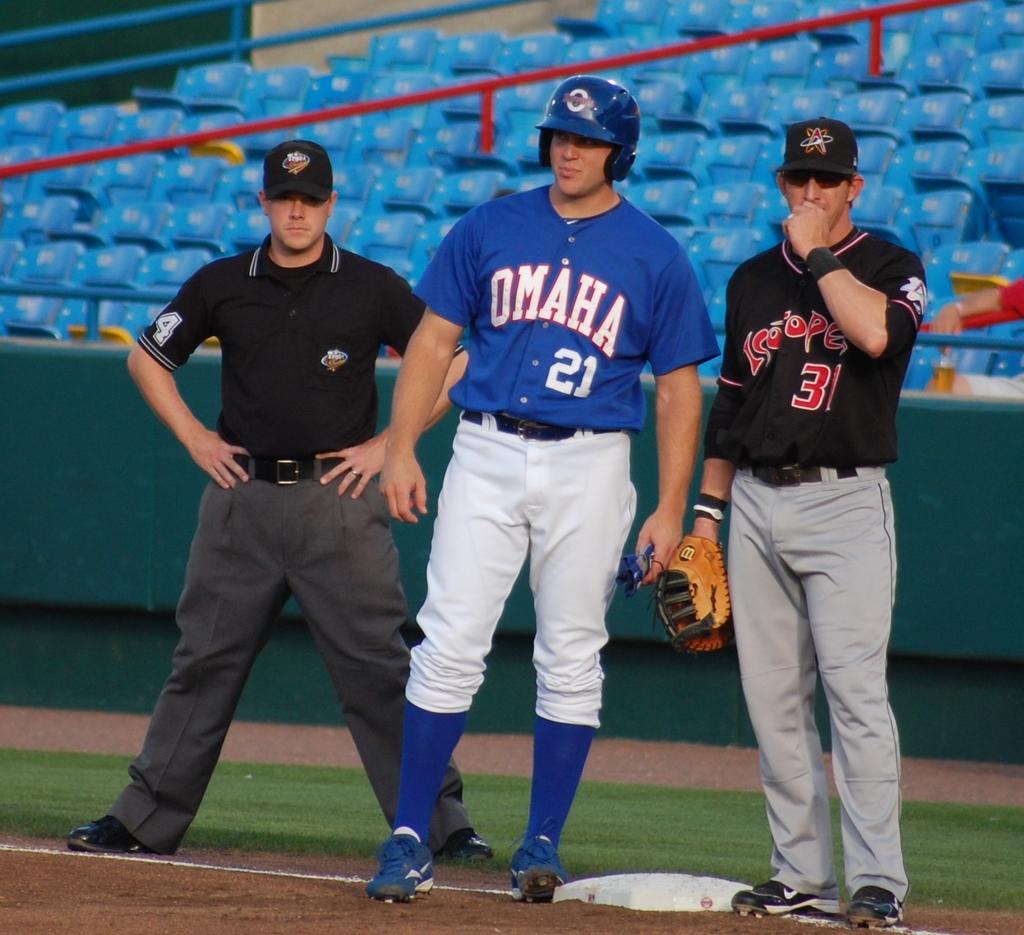What teams are playing?
Keep it short and to the point. Omaha. What is the man in blues jersey number?
Your response must be concise. 21. 